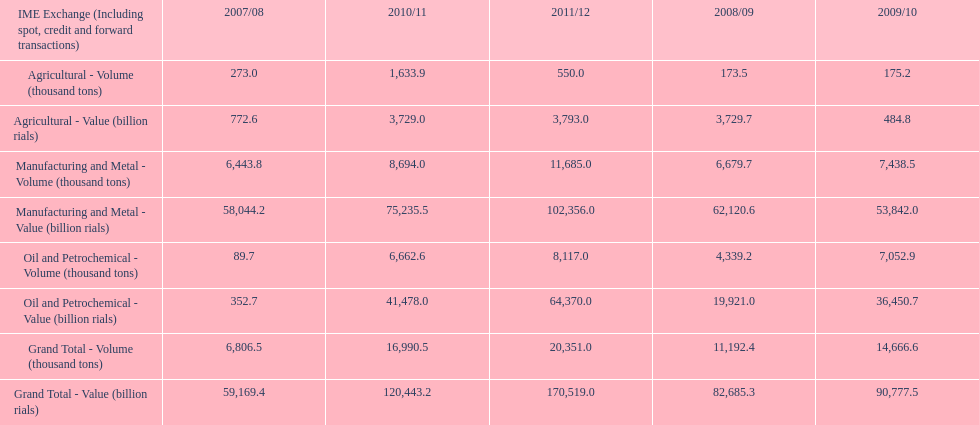Did 2010/11 or 2011/12 make more in grand total value? 2011/12. 